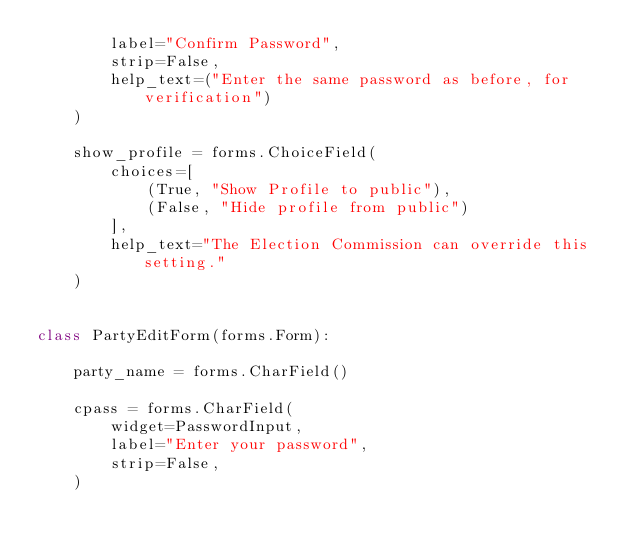Convert code to text. <code><loc_0><loc_0><loc_500><loc_500><_Python_>        label="Confirm Password",
        strip=False,
        help_text=("Enter the same password as before, for verification")
    )

    show_profile = forms.ChoiceField(
        choices=[
            (True, "Show Profile to public"),
            (False, "Hide profile from public")
        ],
        help_text="The Election Commission can override this setting."
    )


class PartyEditForm(forms.Form):

    party_name = forms.CharField()

    cpass = forms.CharField(
        widget=PasswordInput,
        label="Enter your password",
        strip=False,
    )
</code> 